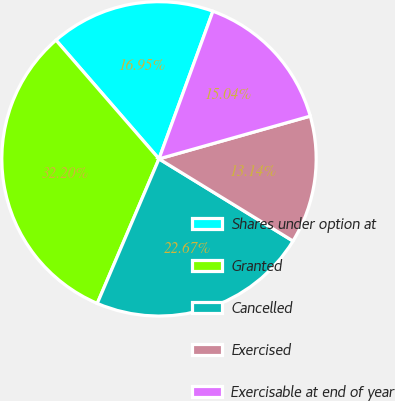Convert chart. <chart><loc_0><loc_0><loc_500><loc_500><pie_chart><fcel>Shares under option at<fcel>Granted<fcel>Cancelled<fcel>Exercised<fcel>Exercisable at end of year<nl><fcel>16.95%<fcel>32.2%<fcel>22.67%<fcel>13.14%<fcel>15.04%<nl></chart> 